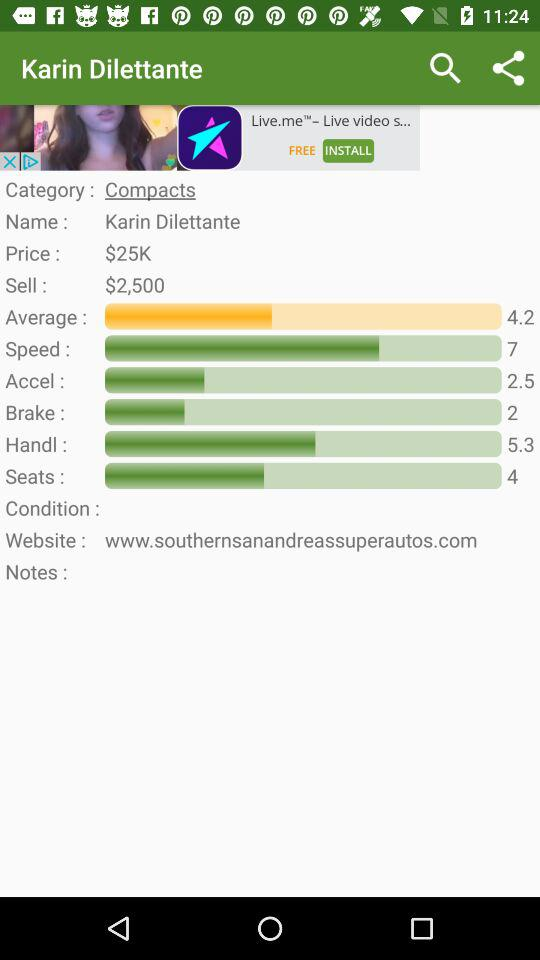What is the average rating of this car?
Answer the question using a single word or phrase. 4.2 